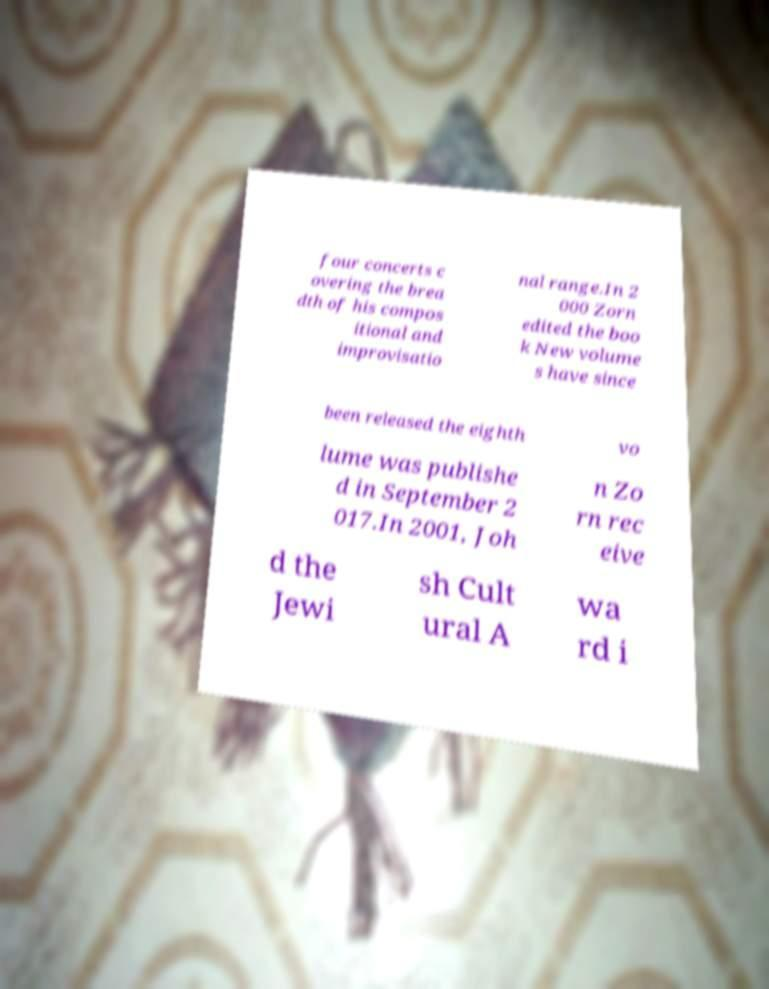Can you read and provide the text displayed in the image?This photo seems to have some interesting text. Can you extract and type it out for me? four concerts c overing the brea dth of his compos itional and improvisatio nal range.In 2 000 Zorn edited the boo k New volume s have since been released the eighth vo lume was publishe d in September 2 017.In 2001, Joh n Zo rn rec eive d the Jewi sh Cult ural A wa rd i 